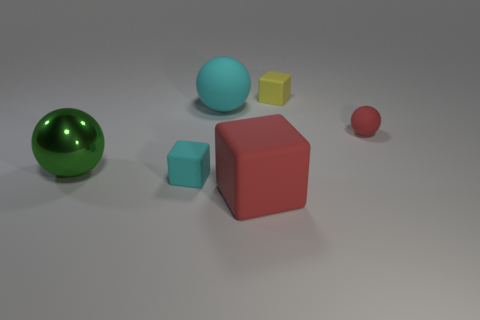Add 1 tiny metal cubes. How many objects exist? 7 Add 3 matte objects. How many matte objects exist? 8 Subtract 1 green spheres. How many objects are left? 5 Subtract all red rubber cubes. Subtract all big red rubber cubes. How many objects are left? 4 Add 5 big matte objects. How many big matte objects are left? 7 